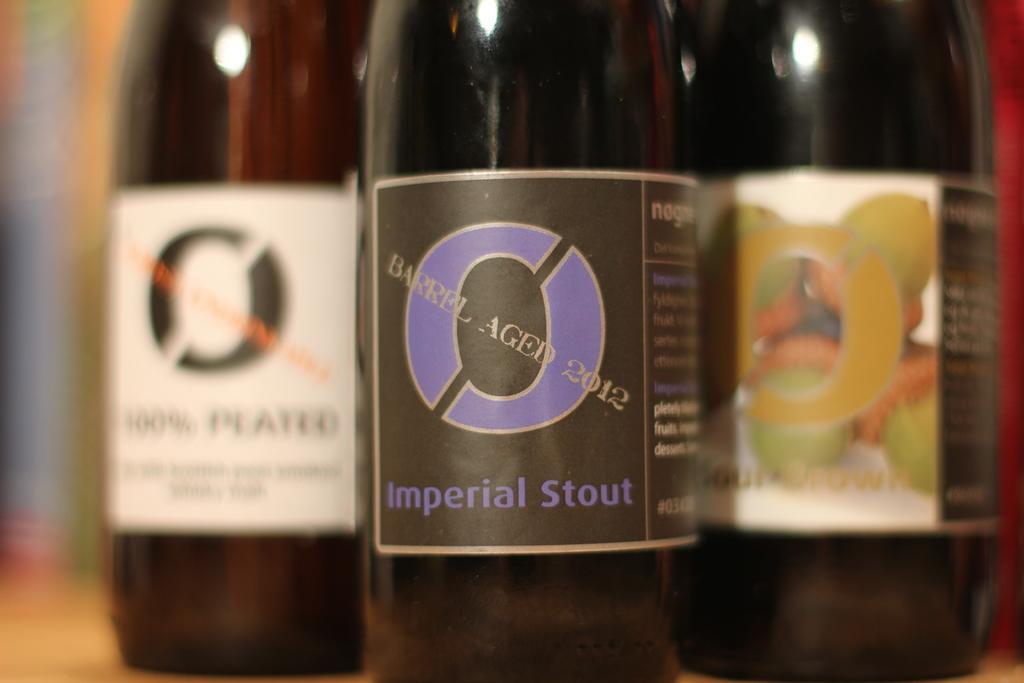In one or two sentences, can you explain what this image depicts? This image consist of 3 bottles. They are in brown color. There are stickers on that. 